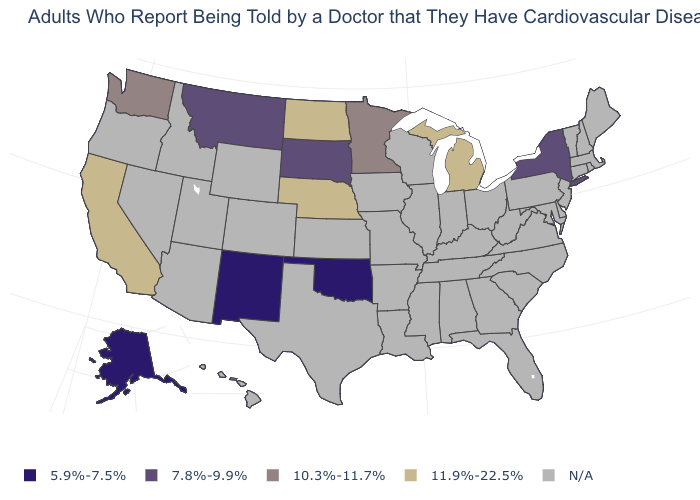What is the highest value in the Northeast ?
Keep it brief. 7.8%-9.9%. What is the value of Maine?
Answer briefly. N/A. Which states have the lowest value in the USA?
Concise answer only. Alaska, New Mexico, Oklahoma. What is the value of New York?
Answer briefly. 7.8%-9.9%. What is the value of Wyoming?
Be succinct. N/A. Does New Mexico have the lowest value in the West?
Be succinct. Yes. Which states have the lowest value in the South?
Give a very brief answer. Oklahoma. Name the states that have a value in the range 5.9%-7.5%?
Quick response, please. Alaska, New Mexico, Oklahoma. Which states have the lowest value in the Northeast?
Answer briefly. New York. What is the lowest value in the West?
Quick response, please. 5.9%-7.5%. What is the value of Ohio?
Keep it brief. N/A. 